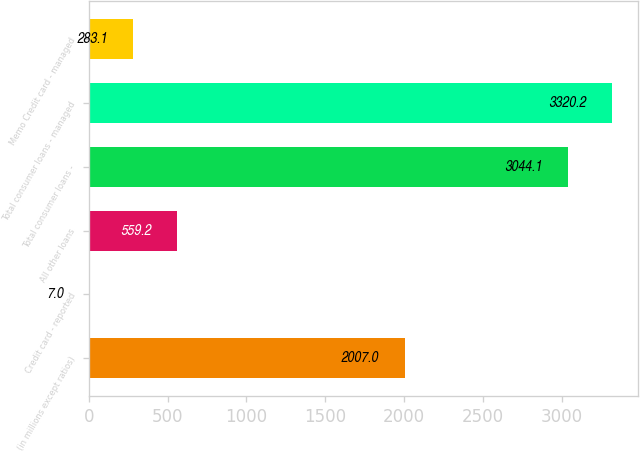<chart> <loc_0><loc_0><loc_500><loc_500><bar_chart><fcel>(in millions except ratios)<fcel>Credit card - reported<fcel>All other loans<fcel>Total consumer loans -<fcel>Total consumer loans - managed<fcel>Memo Credit card - managed<nl><fcel>2007<fcel>7<fcel>559.2<fcel>3044.1<fcel>3320.2<fcel>283.1<nl></chart> 